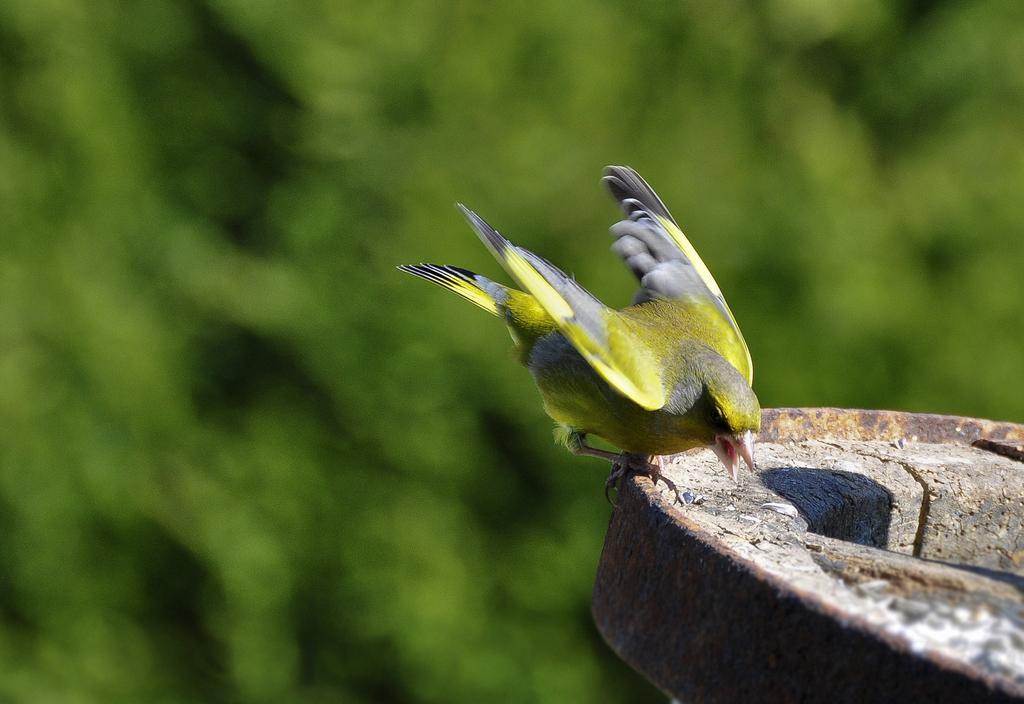Describe this image in one or two sentences. In this image there is a bird on an object. Background is blurry. 